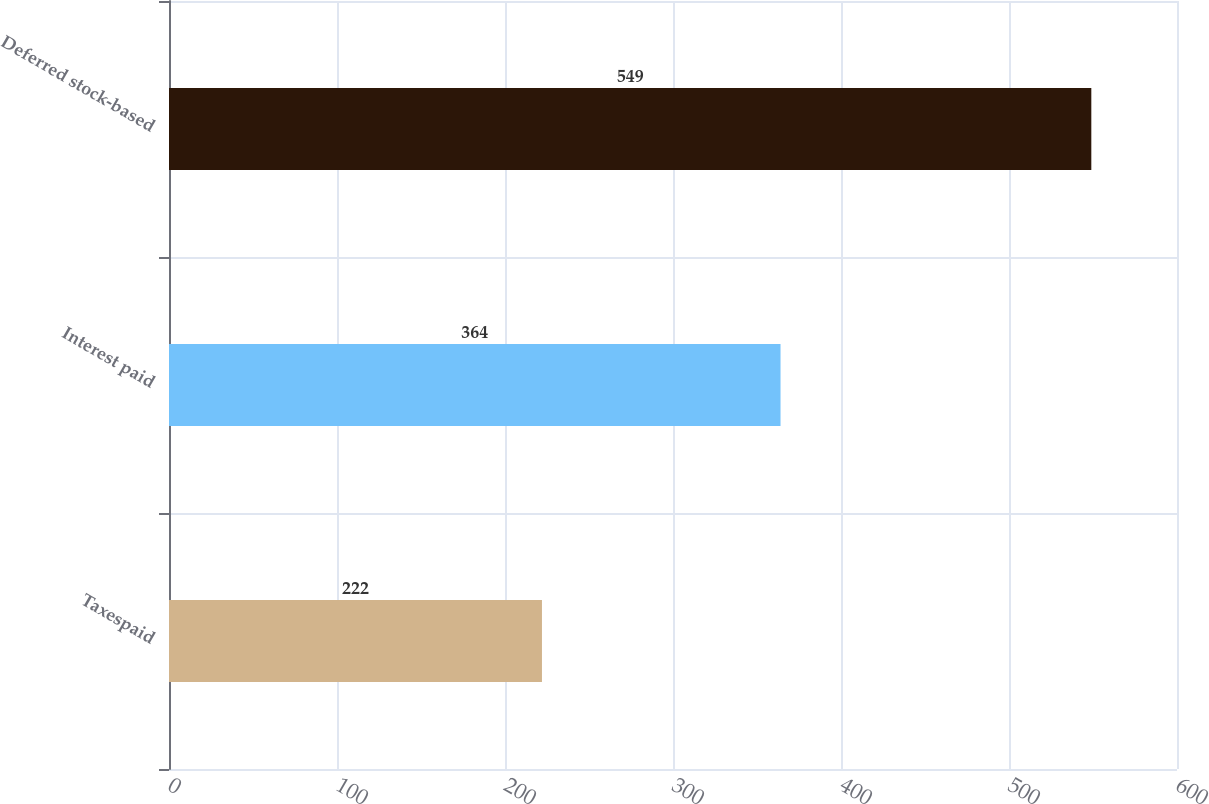<chart> <loc_0><loc_0><loc_500><loc_500><bar_chart><fcel>Taxespaid<fcel>Interest paid<fcel>Deferred stock-based<nl><fcel>222<fcel>364<fcel>549<nl></chart> 